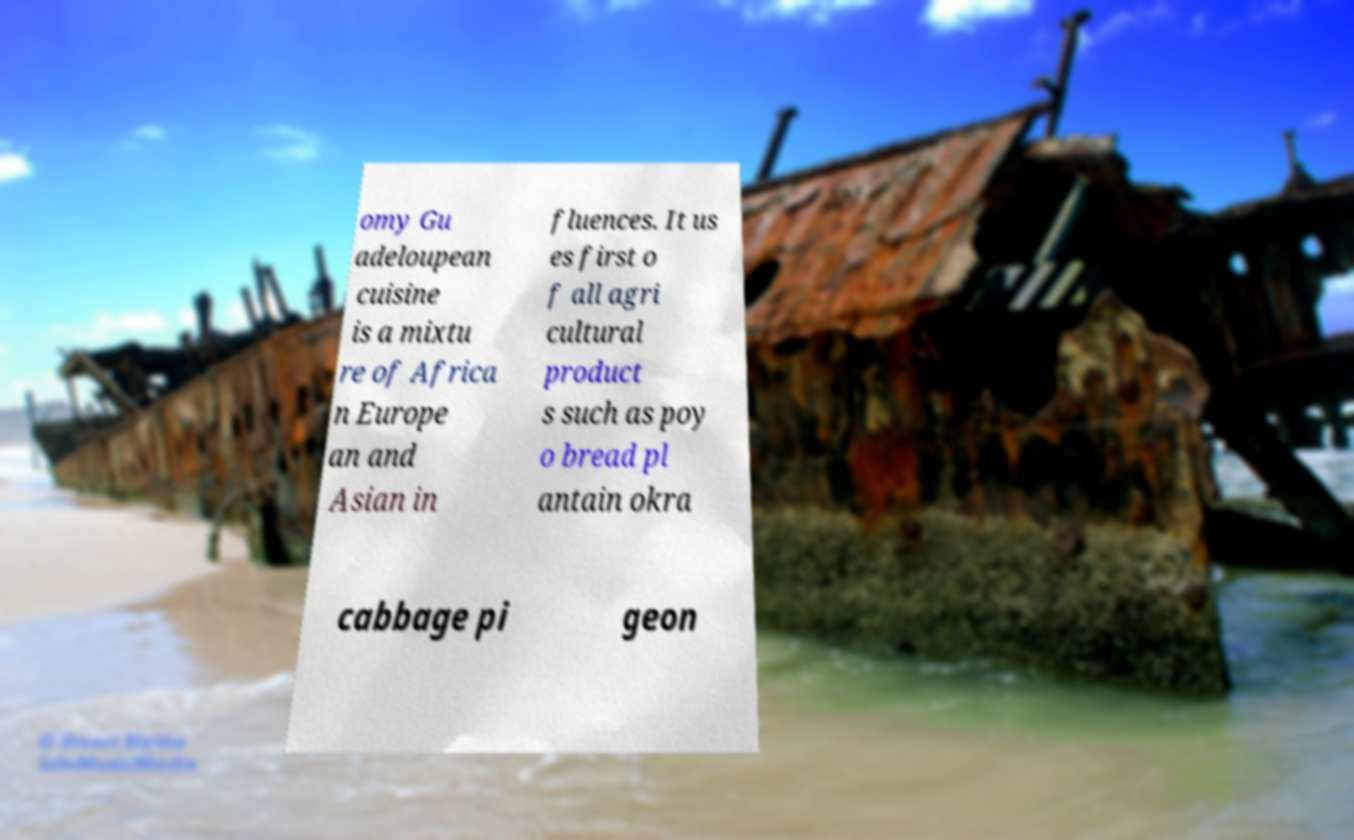For documentation purposes, I need the text within this image transcribed. Could you provide that? omy Gu adeloupean cuisine is a mixtu re of Africa n Europe an and Asian in fluences. It us es first o f all agri cultural product s such as poy o bread pl antain okra cabbage pi geon 